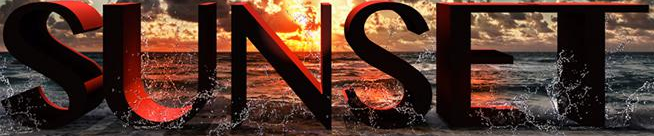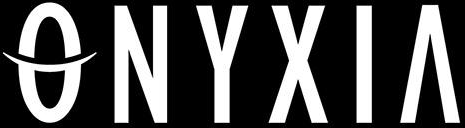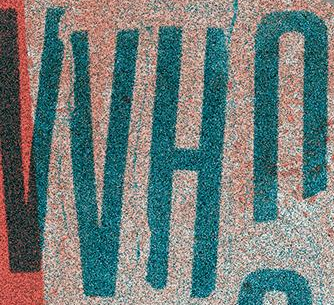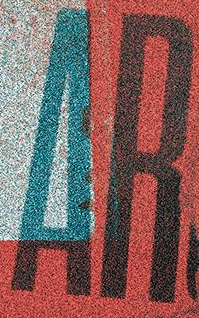Identify the words shown in these images in order, separated by a semicolon. SUNSET; ONYXIA; VVHn; AR 